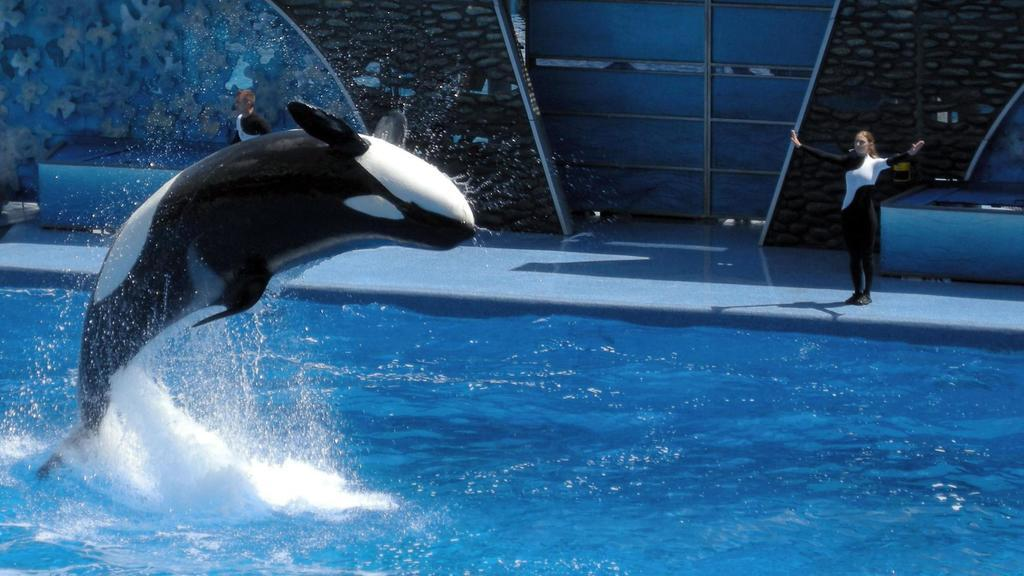What is located at the bottom of the image? There is a swimming pool at the bottom of the image. What is happening in the swimming pool? A dolphin is jumping in the swimming pool. Who is standing on the right side of the image? There is a lady standing on the right side of the image. Can you describe the background of the image? There is a man visible in the background, along with a wall and a door. What flavor of ice cream does the lady suggest to the man in the image? There is no mention of ice cream or a suggestion in the image. Can you see an ant crawling on the wall in the background of the image? There is no ant present in the image. 